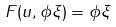<formula> <loc_0><loc_0><loc_500><loc_500>F ( u , \phi \xi ) = \phi \xi</formula> 